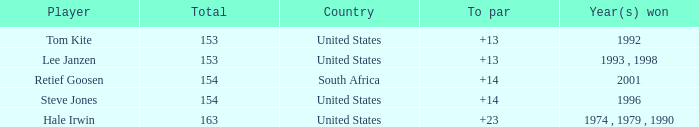In what year did the United States win To par greater than 14 1974 , 1979 , 1990. 